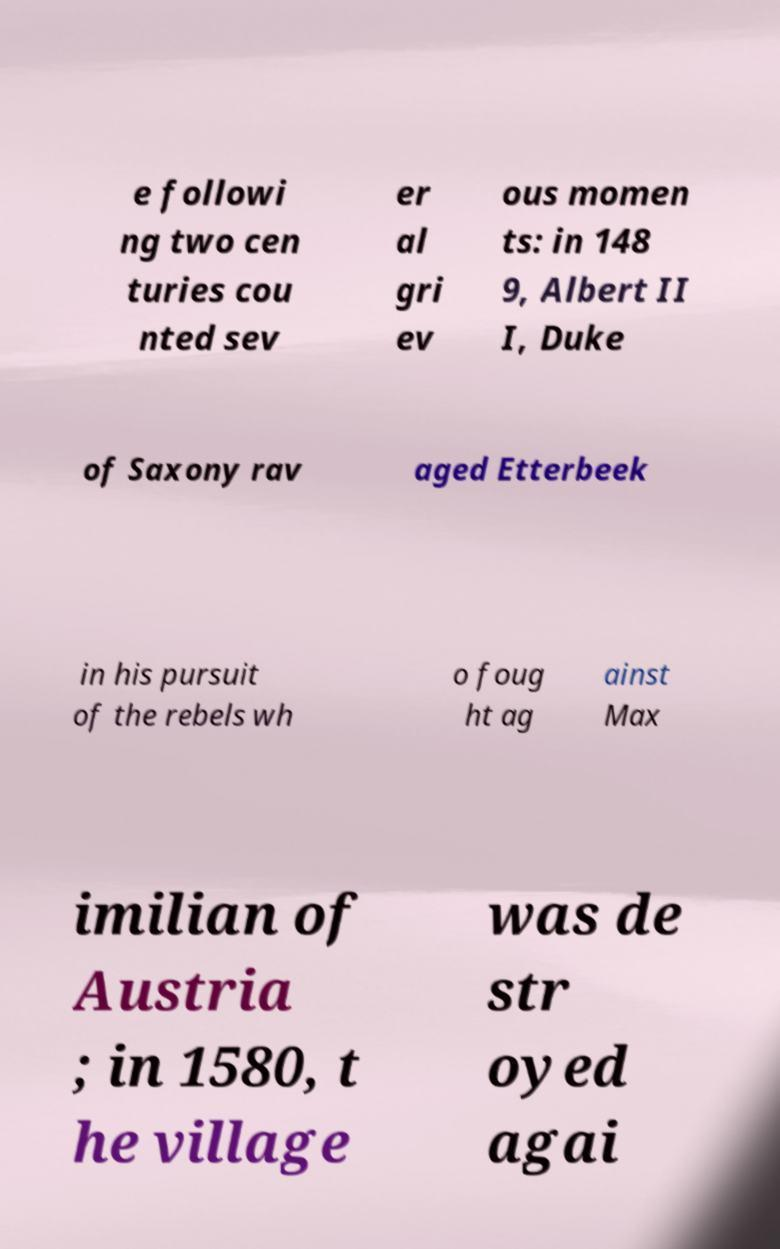Can you read and provide the text displayed in the image?This photo seems to have some interesting text. Can you extract and type it out for me? e followi ng two cen turies cou nted sev er al gri ev ous momen ts: in 148 9, Albert II I, Duke of Saxony rav aged Etterbeek in his pursuit of the rebels wh o foug ht ag ainst Max imilian of Austria ; in 1580, t he village was de str oyed agai 